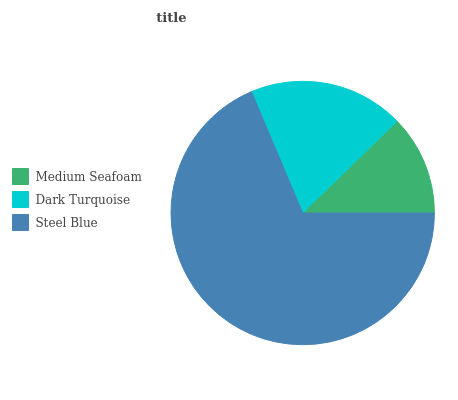Is Medium Seafoam the minimum?
Answer yes or no. Yes. Is Steel Blue the maximum?
Answer yes or no. Yes. Is Dark Turquoise the minimum?
Answer yes or no. No. Is Dark Turquoise the maximum?
Answer yes or no. No. Is Dark Turquoise greater than Medium Seafoam?
Answer yes or no. Yes. Is Medium Seafoam less than Dark Turquoise?
Answer yes or no. Yes. Is Medium Seafoam greater than Dark Turquoise?
Answer yes or no. No. Is Dark Turquoise less than Medium Seafoam?
Answer yes or no. No. Is Dark Turquoise the high median?
Answer yes or no. Yes. Is Dark Turquoise the low median?
Answer yes or no. Yes. Is Steel Blue the high median?
Answer yes or no. No. Is Medium Seafoam the low median?
Answer yes or no. No. 